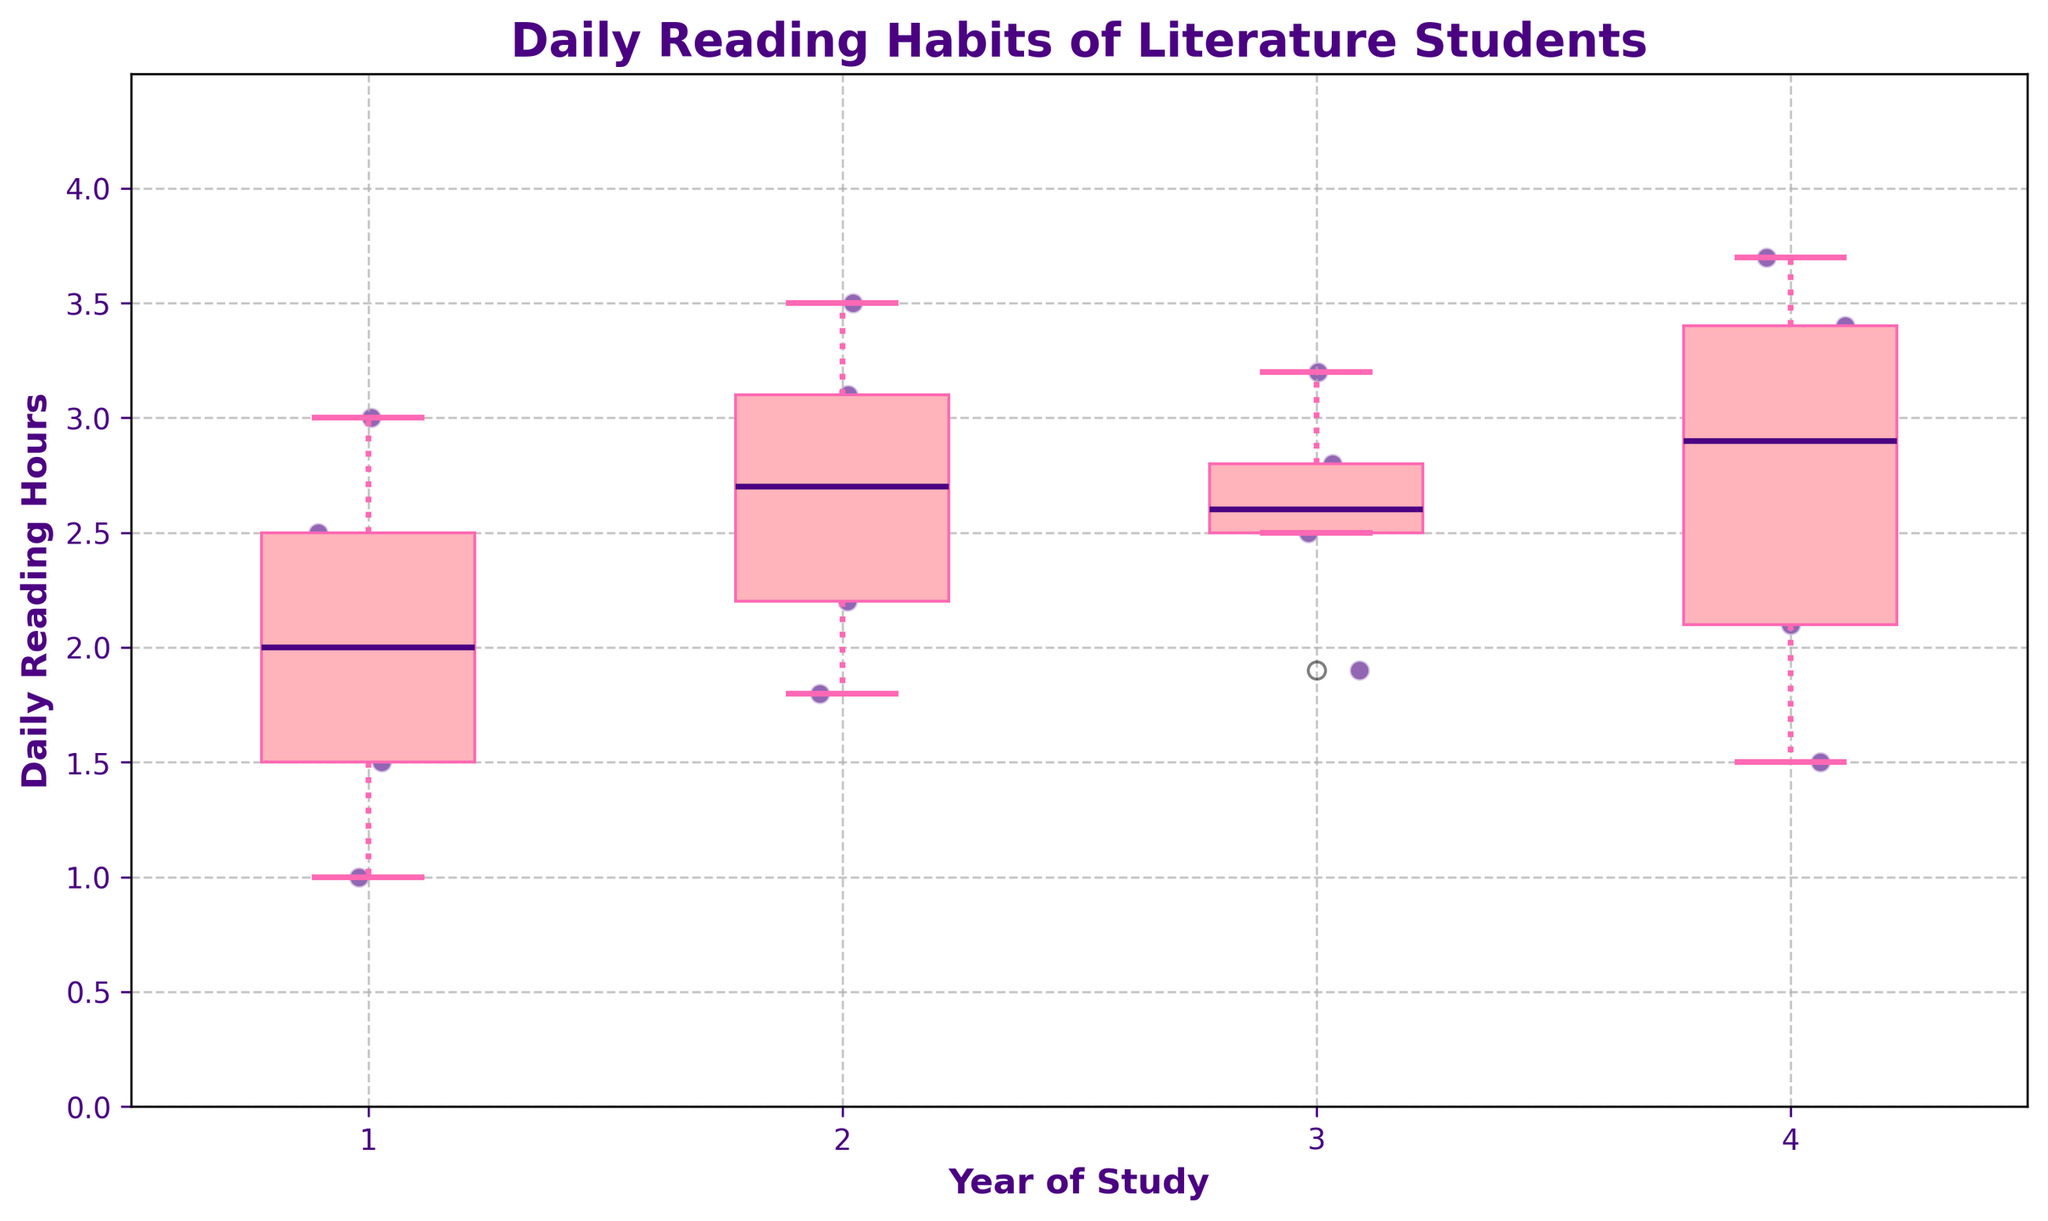How many different years of study are represented in the box plot? The x-axis shows labels for the Year of Study, each representing a distinct year. In this plot, four different years of study are shown.
Answer: 4 What is the title of the box plot? The title is displayed at the top of the plot and helps understand the context of the data represented. Here, the title is "Daily Reading Habits of Literature Students."
Answer: Daily Reading Habits of Literature Students What's the median daily reading hours for first-year students? For the first-year students, the median line inside the box plot is examined. The median value represents the middle value where half the data points lie above and half lie below. The median for the first-year students can be seen around the line in the box plot.
Answer: 2 hours Which year of study has the highest maximum daily reading hours recorded? The maximum daily reading hours for each year can be identified by looking at the top whisker or outlier(s) in each box plot. The year with the whisker or outlier reaching the highest value indicates the highest maximum reading hours. For this plot, the fourth-year students have the highest maximum daily reading hours.
Answer: Fourth-year students Is there any year where no outliers are visible in the scatter plot? Checking each year's box plot scatter points for outliers (outside the whiskers). If all points fit within the whiskers, there are no outliers. Here, the scatter points show no outliers for third-year students.
Answer: Yes, third-year students What's the range of daily reading hours for second-year students? The range is calculated by subtracting the minimum value (bottom whisker or lowest point) from the maximum value (top whisker or highest point). For second-year students, the difference between these values gives the range. The minimum and maximum are approximately 1.8 and 3.5 hours, respectively. Hence, the range is 3.5 - 1.8.
Answer: 1.7 hours What's the interquartile range (IQR) for the daily reading hours of any year? The IQR can be found by subtracting the first quartile (Q1) from the third quartile (Q3) values within any box plot. The first quartile marks the 25th percentile, and the third quartile marks the 75th percentile. For example, for first-year students, Q1 is about 1.5 and Q3 is about 2.5, giving an IQR of 2.5 - 1.5.
Answer: 1 hour (for first-year students) Which year of study shows the most consistent (lowest variability in) daily reading hours? Consistency is indicated by a smaller spread of the box and whiskers. The year with the shortest range between the first and third quartiles and between min and max values indicates low variability. Comparing box lengths, first-year students have the most consistent daily reading hours.
Answer: First-year students In terms of daily reading hours, how do third-year students compare with fourth-year students in terms of variability? Comparing the box plot widths and the range of whiskers of third-year and fourth-year students, the wider box plot and longer whiskers indicate more variability. Fourth-year students show more variability in daily reading hours than third-year students, which show a tighter, more consistent distribution.
Answer: More variability in fourth-year students 